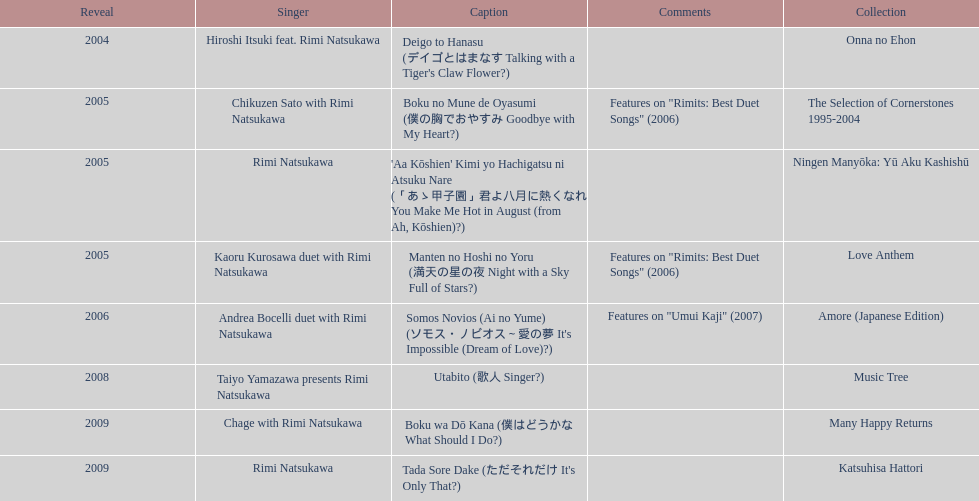How many other appearance did this artist make in 2005? 3. 